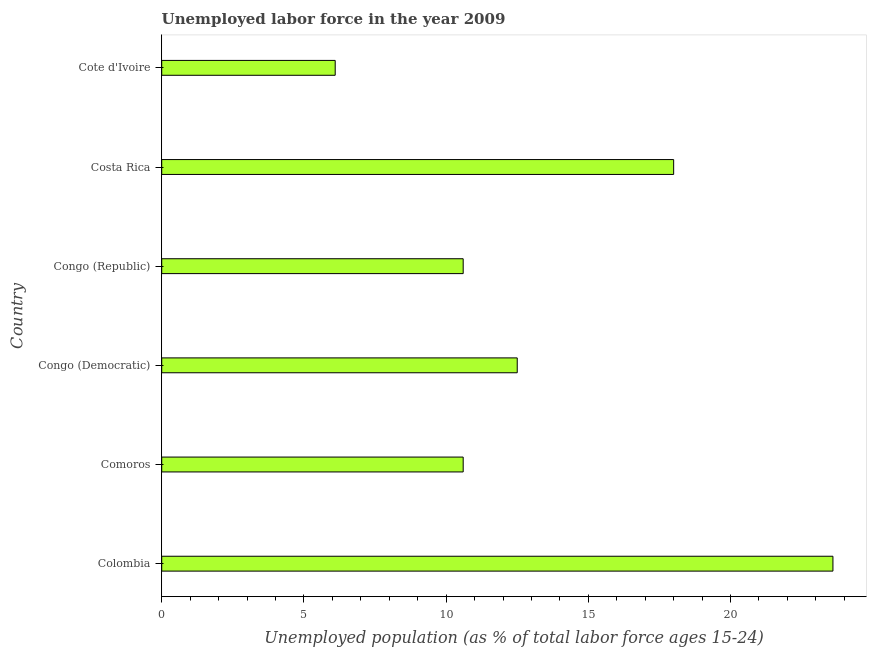Does the graph contain grids?
Your answer should be very brief. No. What is the title of the graph?
Offer a very short reply. Unemployed labor force in the year 2009. What is the label or title of the X-axis?
Your answer should be compact. Unemployed population (as % of total labor force ages 15-24). What is the label or title of the Y-axis?
Your response must be concise. Country. What is the total unemployed youth population in Cote d'Ivoire?
Your answer should be compact. 6.1. Across all countries, what is the maximum total unemployed youth population?
Offer a terse response. 23.6. Across all countries, what is the minimum total unemployed youth population?
Keep it short and to the point. 6.1. In which country was the total unemployed youth population minimum?
Your answer should be very brief. Cote d'Ivoire. What is the sum of the total unemployed youth population?
Ensure brevity in your answer.  81.4. What is the average total unemployed youth population per country?
Give a very brief answer. 13.57. What is the median total unemployed youth population?
Offer a terse response. 11.55. In how many countries, is the total unemployed youth population greater than 10 %?
Provide a succinct answer. 5. What is the ratio of the total unemployed youth population in Comoros to that in Costa Rica?
Provide a short and direct response. 0.59. Is the sum of the total unemployed youth population in Comoros and Congo (Republic) greater than the maximum total unemployed youth population across all countries?
Offer a very short reply. No. How many bars are there?
Your response must be concise. 6. How many countries are there in the graph?
Provide a short and direct response. 6. What is the difference between two consecutive major ticks on the X-axis?
Provide a succinct answer. 5. Are the values on the major ticks of X-axis written in scientific E-notation?
Offer a very short reply. No. What is the Unemployed population (as % of total labor force ages 15-24) of Colombia?
Make the answer very short. 23.6. What is the Unemployed population (as % of total labor force ages 15-24) in Comoros?
Your response must be concise. 10.6. What is the Unemployed population (as % of total labor force ages 15-24) of Congo (Republic)?
Your answer should be very brief. 10.6. What is the Unemployed population (as % of total labor force ages 15-24) of Costa Rica?
Keep it short and to the point. 18. What is the Unemployed population (as % of total labor force ages 15-24) in Cote d'Ivoire?
Keep it short and to the point. 6.1. What is the difference between the Unemployed population (as % of total labor force ages 15-24) in Colombia and Comoros?
Your response must be concise. 13. What is the difference between the Unemployed population (as % of total labor force ages 15-24) in Colombia and Costa Rica?
Offer a very short reply. 5.6. What is the difference between the Unemployed population (as % of total labor force ages 15-24) in Comoros and Congo (Republic)?
Give a very brief answer. 0. What is the difference between the Unemployed population (as % of total labor force ages 15-24) in Congo (Democratic) and Congo (Republic)?
Provide a succinct answer. 1.9. What is the difference between the Unemployed population (as % of total labor force ages 15-24) in Congo (Democratic) and Cote d'Ivoire?
Offer a very short reply. 6.4. What is the difference between the Unemployed population (as % of total labor force ages 15-24) in Congo (Republic) and Costa Rica?
Make the answer very short. -7.4. What is the difference between the Unemployed population (as % of total labor force ages 15-24) in Costa Rica and Cote d'Ivoire?
Give a very brief answer. 11.9. What is the ratio of the Unemployed population (as % of total labor force ages 15-24) in Colombia to that in Comoros?
Offer a terse response. 2.23. What is the ratio of the Unemployed population (as % of total labor force ages 15-24) in Colombia to that in Congo (Democratic)?
Make the answer very short. 1.89. What is the ratio of the Unemployed population (as % of total labor force ages 15-24) in Colombia to that in Congo (Republic)?
Give a very brief answer. 2.23. What is the ratio of the Unemployed population (as % of total labor force ages 15-24) in Colombia to that in Costa Rica?
Provide a succinct answer. 1.31. What is the ratio of the Unemployed population (as % of total labor force ages 15-24) in Colombia to that in Cote d'Ivoire?
Provide a succinct answer. 3.87. What is the ratio of the Unemployed population (as % of total labor force ages 15-24) in Comoros to that in Congo (Democratic)?
Make the answer very short. 0.85. What is the ratio of the Unemployed population (as % of total labor force ages 15-24) in Comoros to that in Costa Rica?
Provide a short and direct response. 0.59. What is the ratio of the Unemployed population (as % of total labor force ages 15-24) in Comoros to that in Cote d'Ivoire?
Make the answer very short. 1.74. What is the ratio of the Unemployed population (as % of total labor force ages 15-24) in Congo (Democratic) to that in Congo (Republic)?
Ensure brevity in your answer.  1.18. What is the ratio of the Unemployed population (as % of total labor force ages 15-24) in Congo (Democratic) to that in Costa Rica?
Make the answer very short. 0.69. What is the ratio of the Unemployed population (as % of total labor force ages 15-24) in Congo (Democratic) to that in Cote d'Ivoire?
Ensure brevity in your answer.  2.05. What is the ratio of the Unemployed population (as % of total labor force ages 15-24) in Congo (Republic) to that in Costa Rica?
Your answer should be compact. 0.59. What is the ratio of the Unemployed population (as % of total labor force ages 15-24) in Congo (Republic) to that in Cote d'Ivoire?
Make the answer very short. 1.74. What is the ratio of the Unemployed population (as % of total labor force ages 15-24) in Costa Rica to that in Cote d'Ivoire?
Your answer should be compact. 2.95. 